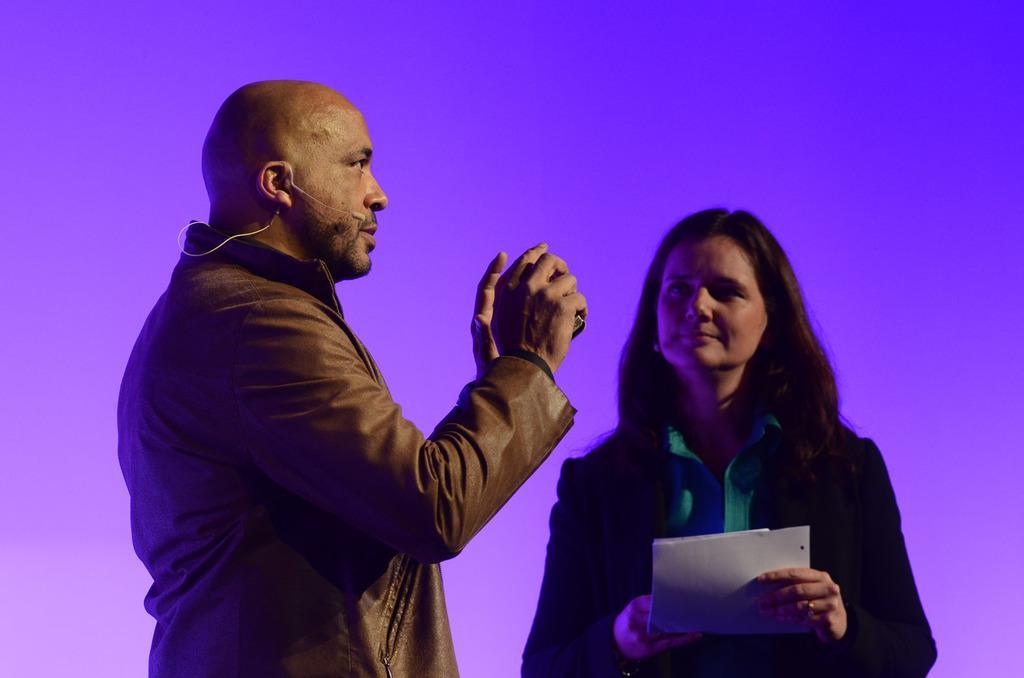Can you describe this image briefly? In this picture we can see a man and a woman, she is holding a paper in her hands. and we can see a microphone. 